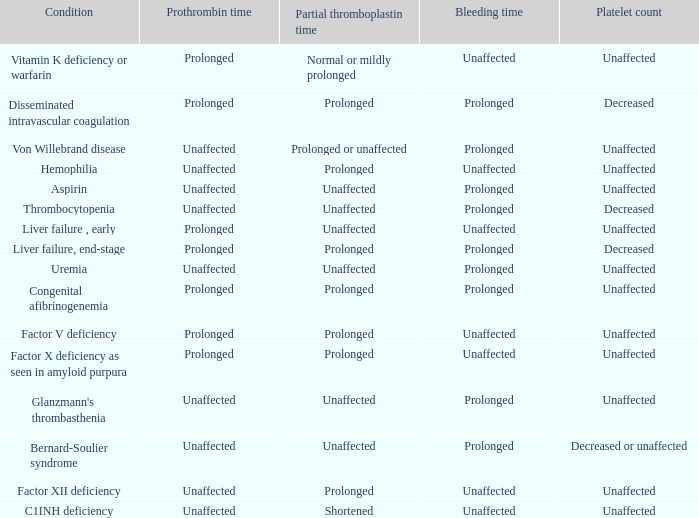Which Prothrombin time has a Platelet count of unaffected, and a Bleeding time of unaffected, and a Partial thromboplastin time of normal or mildly prolonged? Prolonged. 